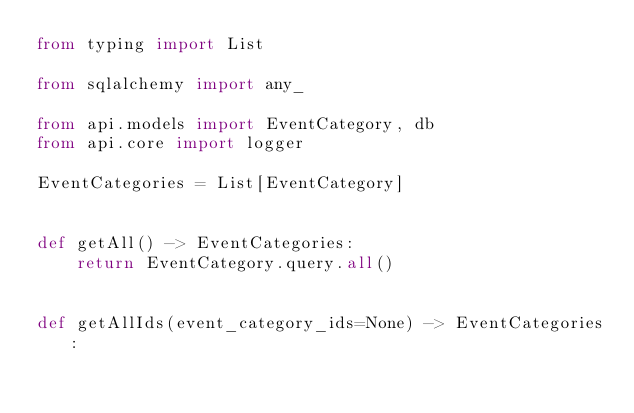Convert code to text. <code><loc_0><loc_0><loc_500><loc_500><_Python_>from typing import List

from sqlalchemy import any_

from api.models import EventCategory, db
from api.core import logger

EventCategories = List[EventCategory]


def getAll() -> EventCategories:
    return EventCategory.query.all()


def getAllIds(event_category_ids=None) -> EventCategories:</code> 